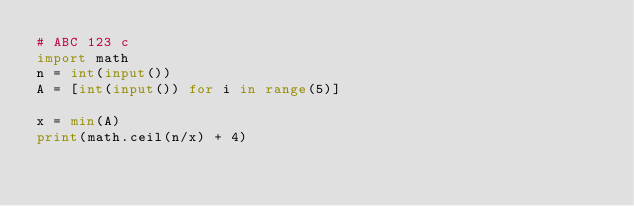Convert code to text. <code><loc_0><loc_0><loc_500><loc_500><_Python_># ABC 123 c
import math
n = int(input())
A = [int(input()) for i in range(5)]

x = min(A)
print(math.ceil(n/x) + 4)
</code> 